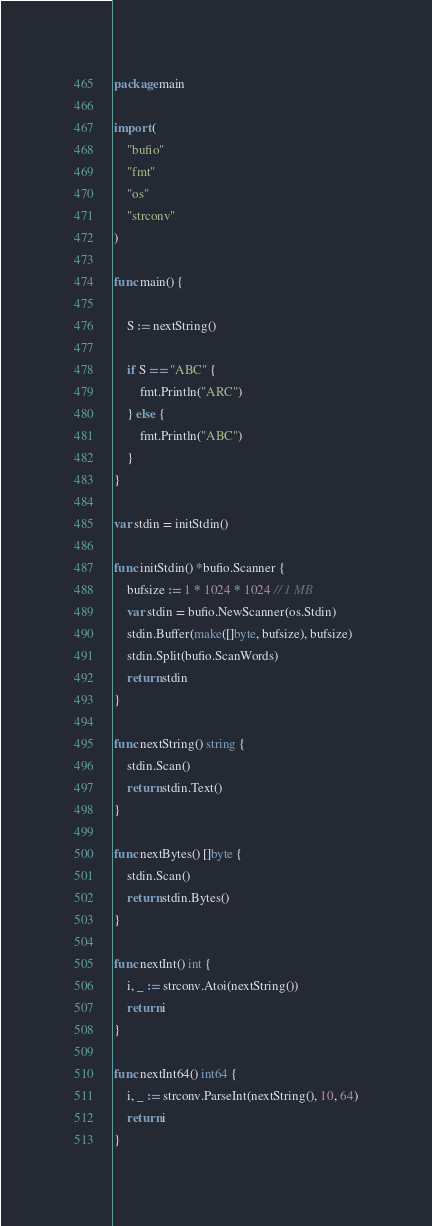Convert code to text. <code><loc_0><loc_0><loc_500><loc_500><_Go_>package main

import (
	"bufio"
	"fmt"
	"os"
	"strconv"
)

func main() {

	S := nextString()

	if S == "ABC" {
		fmt.Println("ARC")
	} else {
		fmt.Println("ABC")
	}
}

var stdin = initStdin()

func initStdin() *bufio.Scanner {
	bufsize := 1 * 1024 * 1024 // 1 MB
	var stdin = bufio.NewScanner(os.Stdin)
	stdin.Buffer(make([]byte, bufsize), bufsize)
	stdin.Split(bufio.ScanWords)
	return stdin
}

func nextString() string {
	stdin.Scan()
	return stdin.Text()
}

func nextBytes() []byte {
	stdin.Scan()
	return stdin.Bytes()
}

func nextInt() int {
	i, _ := strconv.Atoi(nextString())
	return i
}

func nextInt64() int64 {
	i, _ := strconv.ParseInt(nextString(), 10, 64)
	return i
}
</code> 